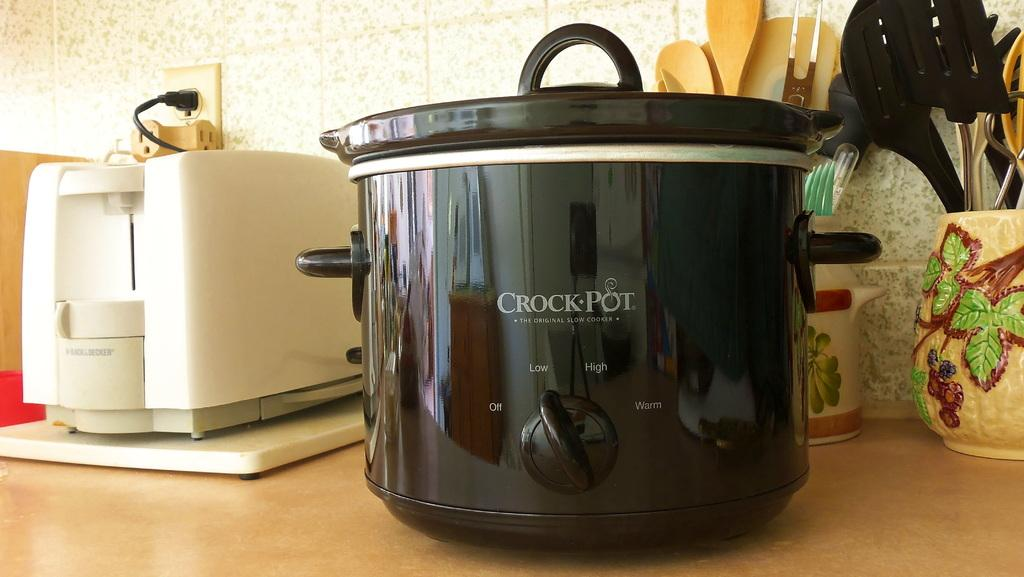<image>
Render a clear and concise summary of the photo. a black crockpot next to a white toaster on a countertop 